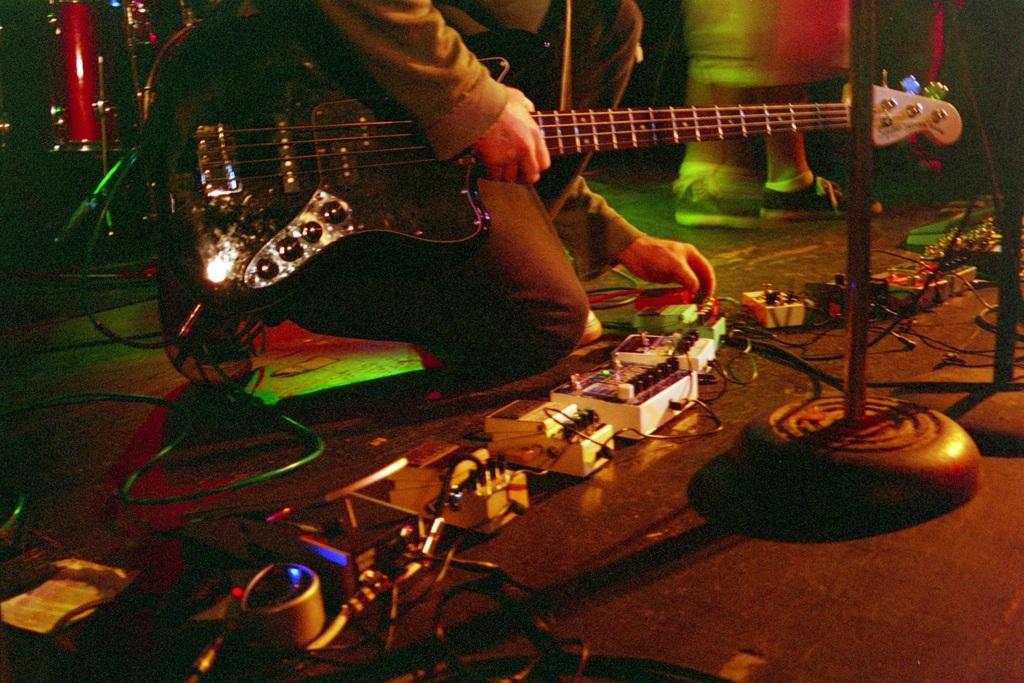What is the man in the image holding? The man is holding a guitar in the image. What is the man doing with the switches? The man is arranging switches in the image. How many people are present in the image? There are two men in the image. What other objects can be seen in the image besides the guitar and switches? There are musical instruments in the image. What type of volleyball is being served during the lunch break in the image? There is no volleyball or lunch break depicted in the image; it features a man holding a guitar and arranging switches. How old is the boy playing the musical instruments in the image? There is no boy present in the image; it features two men, one holding a guitar and the other arranging switches. 